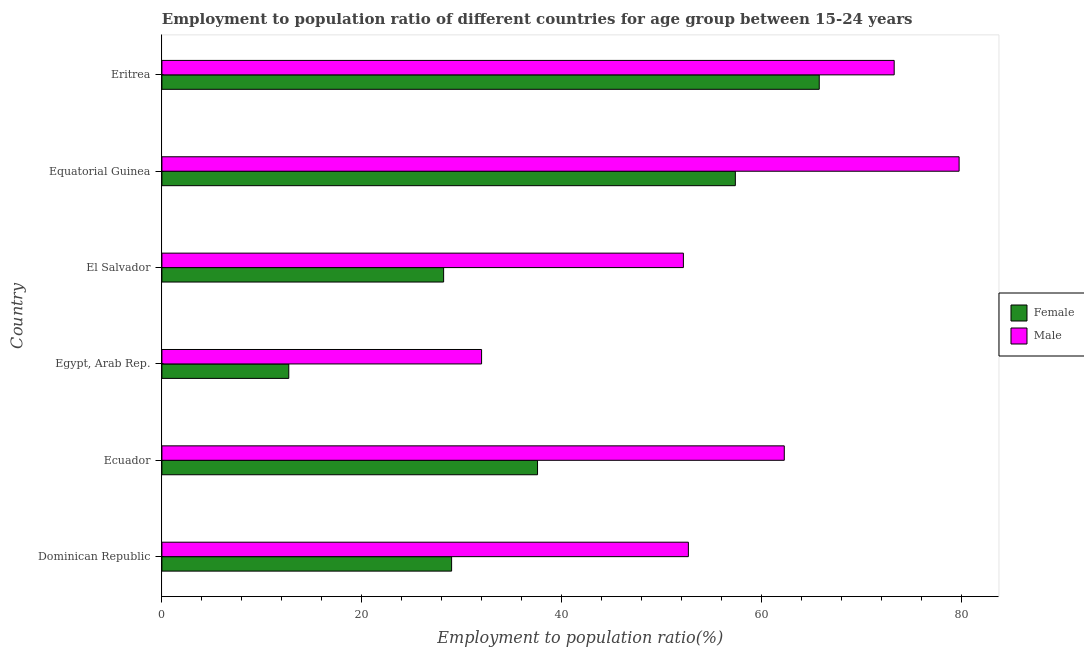How many groups of bars are there?
Provide a succinct answer. 6. Are the number of bars per tick equal to the number of legend labels?
Keep it short and to the point. Yes. Are the number of bars on each tick of the Y-axis equal?
Provide a succinct answer. Yes. What is the label of the 1st group of bars from the top?
Your answer should be very brief. Eritrea. In how many cases, is the number of bars for a given country not equal to the number of legend labels?
Give a very brief answer. 0. What is the employment to population ratio(male) in Equatorial Guinea?
Your response must be concise. 79.8. Across all countries, what is the maximum employment to population ratio(female)?
Keep it short and to the point. 65.8. Across all countries, what is the minimum employment to population ratio(female)?
Offer a terse response. 12.7. In which country was the employment to population ratio(male) maximum?
Offer a very short reply. Equatorial Guinea. In which country was the employment to population ratio(female) minimum?
Your answer should be very brief. Egypt, Arab Rep. What is the total employment to population ratio(male) in the graph?
Provide a short and direct response. 352.3. What is the difference between the employment to population ratio(male) in Ecuador and that in Eritrea?
Provide a succinct answer. -11. What is the difference between the employment to population ratio(female) in Equatorial Guinea and the employment to population ratio(male) in Egypt, Arab Rep.?
Your answer should be very brief. 25.4. What is the average employment to population ratio(male) per country?
Your answer should be very brief. 58.72. What is the difference between the employment to population ratio(female) and employment to population ratio(male) in Dominican Republic?
Provide a succinct answer. -23.7. In how many countries, is the employment to population ratio(male) greater than 44 %?
Offer a very short reply. 5. What is the ratio of the employment to population ratio(male) in Dominican Republic to that in Ecuador?
Provide a short and direct response. 0.85. What is the difference between the highest and the lowest employment to population ratio(male)?
Offer a very short reply. 47.8. In how many countries, is the employment to population ratio(male) greater than the average employment to population ratio(male) taken over all countries?
Ensure brevity in your answer.  3. Is the sum of the employment to population ratio(female) in Egypt, Arab Rep. and El Salvador greater than the maximum employment to population ratio(male) across all countries?
Offer a very short reply. No. Are all the bars in the graph horizontal?
Your answer should be compact. Yes. How many countries are there in the graph?
Ensure brevity in your answer.  6. What is the difference between two consecutive major ticks on the X-axis?
Ensure brevity in your answer.  20. Are the values on the major ticks of X-axis written in scientific E-notation?
Offer a very short reply. No. Does the graph contain any zero values?
Make the answer very short. No. Does the graph contain grids?
Offer a terse response. No. What is the title of the graph?
Offer a very short reply. Employment to population ratio of different countries for age group between 15-24 years. What is the label or title of the Y-axis?
Offer a terse response. Country. What is the Employment to population ratio(%) of Female in Dominican Republic?
Provide a short and direct response. 29. What is the Employment to population ratio(%) of Male in Dominican Republic?
Offer a very short reply. 52.7. What is the Employment to population ratio(%) in Female in Ecuador?
Make the answer very short. 37.6. What is the Employment to population ratio(%) of Male in Ecuador?
Ensure brevity in your answer.  62.3. What is the Employment to population ratio(%) in Female in Egypt, Arab Rep.?
Provide a succinct answer. 12.7. What is the Employment to population ratio(%) in Male in Egypt, Arab Rep.?
Make the answer very short. 32. What is the Employment to population ratio(%) of Female in El Salvador?
Your answer should be compact. 28.2. What is the Employment to population ratio(%) in Male in El Salvador?
Offer a terse response. 52.2. What is the Employment to population ratio(%) in Female in Equatorial Guinea?
Your response must be concise. 57.4. What is the Employment to population ratio(%) in Male in Equatorial Guinea?
Provide a short and direct response. 79.8. What is the Employment to population ratio(%) of Female in Eritrea?
Offer a terse response. 65.8. What is the Employment to population ratio(%) in Male in Eritrea?
Provide a short and direct response. 73.3. Across all countries, what is the maximum Employment to population ratio(%) of Female?
Your response must be concise. 65.8. Across all countries, what is the maximum Employment to population ratio(%) of Male?
Offer a very short reply. 79.8. Across all countries, what is the minimum Employment to population ratio(%) in Female?
Make the answer very short. 12.7. Across all countries, what is the minimum Employment to population ratio(%) in Male?
Your response must be concise. 32. What is the total Employment to population ratio(%) in Female in the graph?
Your response must be concise. 230.7. What is the total Employment to population ratio(%) in Male in the graph?
Your answer should be very brief. 352.3. What is the difference between the Employment to population ratio(%) in Male in Dominican Republic and that in Ecuador?
Your answer should be compact. -9.6. What is the difference between the Employment to population ratio(%) of Female in Dominican Republic and that in Egypt, Arab Rep.?
Your answer should be very brief. 16.3. What is the difference between the Employment to population ratio(%) in Male in Dominican Republic and that in Egypt, Arab Rep.?
Offer a very short reply. 20.7. What is the difference between the Employment to population ratio(%) in Female in Dominican Republic and that in El Salvador?
Give a very brief answer. 0.8. What is the difference between the Employment to population ratio(%) in Male in Dominican Republic and that in El Salvador?
Your answer should be compact. 0.5. What is the difference between the Employment to population ratio(%) in Female in Dominican Republic and that in Equatorial Guinea?
Provide a succinct answer. -28.4. What is the difference between the Employment to population ratio(%) in Male in Dominican Republic and that in Equatorial Guinea?
Your answer should be very brief. -27.1. What is the difference between the Employment to population ratio(%) in Female in Dominican Republic and that in Eritrea?
Keep it short and to the point. -36.8. What is the difference between the Employment to population ratio(%) in Male in Dominican Republic and that in Eritrea?
Your answer should be compact. -20.6. What is the difference between the Employment to population ratio(%) in Female in Ecuador and that in Egypt, Arab Rep.?
Your answer should be very brief. 24.9. What is the difference between the Employment to population ratio(%) in Male in Ecuador and that in Egypt, Arab Rep.?
Provide a short and direct response. 30.3. What is the difference between the Employment to population ratio(%) in Female in Ecuador and that in Equatorial Guinea?
Offer a very short reply. -19.8. What is the difference between the Employment to population ratio(%) in Male in Ecuador and that in Equatorial Guinea?
Keep it short and to the point. -17.5. What is the difference between the Employment to population ratio(%) in Female in Ecuador and that in Eritrea?
Offer a terse response. -28.2. What is the difference between the Employment to population ratio(%) in Male in Ecuador and that in Eritrea?
Provide a succinct answer. -11. What is the difference between the Employment to population ratio(%) of Female in Egypt, Arab Rep. and that in El Salvador?
Provide a short and direct response. -15.5. What is the difference between the Employment to population ratio(%) in Male in Egypt, Arab Rep. and that in El Salvador?
Keep it short and to the point. -20.2. What is the difference between the Employment to population ratio(%) in Female in Egypt, Arab Rep. and that in Equatorial Guinea?
Keep it short and to the point. -44.7. What is the difference between the Employment to population ratio(%) in Male in Egypt, Arab Rep. and that in Equatorial Guinea?
Your answer should be compact. -47.8. What is the difference between the Employment to population ratio(%) in Female in Egypt, Arab Rep. and that in Eritrea?
Keep it short and to the point. -53.1. What is the difference between the Employment to population ratio(%) in Male in Egypt, Arab Rep. and that in Eritrea?
Ensure brevity in your answer.  -41.3. What is the difference between the Employment to population ratio(%) of Female in El Salvador and that in Equatorial Guinea?
Your answer should be compact. -29.2. What is the difference between the Employment to population ratio(%) in Male in El Salvador and that in Equatorial Guinea?
Your answer should be very brief. -27.6. What is the difference between the Employment to population ratio(%) of Female in El Salvador and that in Eritrea?
Keep it short and to the point. -37.6. What is the difference between the Employment to population ratio(%) in Male in El Salvador and that in Eritrea?
Give a very brief answer. -21.1. What is the difference between the Employment to population ratio(%) of Female in Equatorial Guinea and that in Eritrea?
Keep it short and to the point. -8.4. What is the difference between the Employment to population ratio(%) in Male in Equatorial Guinea and that in Eritrea?
Offer a very short reply. 6.5. What is the difference between the Employment to population ratio(%) of Female in Dominican Republic and the Employment to population ratio(%) of Male in Ecuador?
Ensure brevity in your answer.  -33.3. What is the difference between the Employment to population ratio(%) in Female in Dominican Republic and the Employment to population ratio(%) in Male in El Salvador?
Your response must be concise. -23.2. What is the difference between the Employment to population ratio(%) in Female in Dominican Republic and the Employment to population ratio(%) in Male in Equatorial Guinea?
Provide a short and direct response. -50.8. What is the difference between the Employment to population ratio(%) of Female in Dominican Republic and the Employment to population ratio(%) of Male in Eritrea?
Your answer should be very brief. -44.3. What is the difference between the Employment to population ratio(%) of Female in Ecuador and the Employment to population ratio(%) of Male in Egypt, Arab Rep.?
Offer a very short reply. 5.6. What is the difference between the Employment to population ratio(%) in Female in Ecuador and the Employment to population ratio(%) in Male in El Salvador?
Offer a terse response. -14.6. What is the difference between the Employment to population ratio(%) in Female in Ecuador and the Employment to population ratio(%) in Male in Equatorial Guinea?
Offer a terse response. -42.2. What is the difference between the Employment to population ratio(%) in Female in Ecuador and the Employment to population ratio(%) in Male in Eritrea?
Your answer should be compact. -35.7. What is the difference between the Employment to population ratio(%) of Female in Egypt, Arab Rep. and the Employment to population ratio(%) of Male in El Salvador?
Your answer should be compact. -39.5. What is the difference between the Employment to population ratio(%) in Female in Egypt, Arab Rep. and the Employment to population ratio(%) in Male in Equatorial Guinea?
Provide a succinct answer. -67.1. What is the difference between the Employment to population ratio(%) in Female in Egypt, Arab Rep. and the Employment to population ratio(%) in Male in Eritrea?
Your answer should be compact. -60.6. What is the difference between the Employment to population ratio(%) in Female in El Salvador and the Employment to population ratio(%) in Male in Equatorial Guinea?
Your response must be concise. -51.6. What is the difference between the Employment to population ratio(%) in Female in El Salvador and the Employment to population ratio(%) in Male in Eritrea?
Your answer should be compact. -45.1. What is the difference between the Employment to population ratio(%) in Female in Equatorial Guinea and the Employment to population ratio(%) in Male in Eritrea?
Offer a very short reply. -15.9. What is the average Employment to population ratio(%) of Female per country?
Provide a succinct answer. 38.45. What is the average Employment to population ratio(%) in Male per country?
Provide a short and direct response. 58.72. What is the difference between the Employment to population ratio(%) of Female and Employment to population ratio(%) of Male in Dominican Republic?
Make the answer very short. -23.7. What is the difference between the Employment to population ratio(%) of Female and Employment to population ratio(%) of Male in Ecuador?
Your answer should be very brief. -24.7. What is the difference between the Employment to population ratio(%) of Female and Employment to population ratio(%) of Male in Egypt, Arab Rep.?
Keep it short and to the point. -19.3. What is the difference between the Employment to population ratio(%) of Female and Employment to population ratio(%) of Male in Equatorial Guinea?
Provide a succinct answer. -22.4. What is the ratio of the Employment to population ratio(%) in Female in Dominican Republic to that in Ecuador?
Offer a terse response. 0.77. What is the ratio of the Employment to population ratio(%) of Male in Dominican Republic to that in Ecuador?
Make the answer very short. 0.85. What is the ratio of the Employment to population ratio(%) of Female in Dominican Republic to that in Egypt, Arab Rep.?
Offer a terse response. 2.28. What is the ratio of the Employment to population ratio(%) in Male in Dominican Republic to that in Egypt, Arab Rep.?
Make the answer very short. 1.65. What is the ratio of the Employment to population ratio(%) of Female in Dominican Republic to that in El Salvador?
Provide a succinct answer. 1.03. What is the ratio of the Employment to population ratio(%) of Male in Dominican Republic to that in El Salvador?
Keep it short and to the point. 1.01. What is the ratio of the Employment to population ratio(%) in Female in Dominican Republic to that in Equatorial Guinea?
Provide a short and direct response. 0.51. What is the ratio of the Employment to population ratio(%) of Male in Dominican Republic to that in Equatorial Guinea?
Ensure brevity in your answer.  0.66. What is the ratio of the Employment to population ratio(%) in Female in Dominican Republic to that in Eritrea?
Offer a very short reply. 0.44. What is the ratio of the Employment to population ratio(%) in Male in Dominican Republic to that in Eritrea?
Provide a succinct answer. 0.72. What is the ratio of the Employment to population ratio(%) in Female in Ecuador to that in Egypt, Arab Rep.?
Offer a terse response. 2.96. What is the ratio of the Employment to population ratio(%) of Male in Ecuador to that in Egypt, Arab Rep.?
Your response must be concise. 1.95. What is the ratio of the Employment to population ratio(%) in Female in Ecuador to that in El Salvador?
Your response must be concise. 1.33. What is the ratio of the Employment to population ratio(%) of Male in Ecuador to that in El Salvador?
Offer a very short reply. 1.19. What is the ratio of the Employment to population ratio(%) of Female in Ecuador to that in Equatorial Guinea?
Ensure brevity in your answer.  0.66. What is the ratio of the Employment to population ratio(%) of Male in Ecuador to that in Equatorial Guinea?
Provide a short and direct response. 0.78. What is the ratio of the Employment to population ratio(%) in Male in Ecuador to that in Eritrea?
Provide a succinct answer. 0.85. What is the ratio of the Employment to population ratio(%) of Female in Egypt, Arab Rep. to that in El Salvador?
Your response must be concise. 0.45. What is the ratio of the Employment to population ratio(%) in Male in Egypt, Arab Rep. to that in El Salvador?
Offer a very short reply. 0.61. What is the ratio of the Employment to population ratio(%) in Female in Egypt, Arab Rep. to that in Equatorial Guinea?
Provide a short and direct response. 0.22. What is the ratio of the Employment to population ratio(%) of Male in Egypt, Arab Rep. to that in Equatorial Guinea?
Give a very brief answer. 0.4. What is the ratio of the Employment to population ratio(%) of Female in Egypt, Arab Rep. to that in Eritrea?
Make the answer very short. 0.19. What is the ratio of the Employment to population ratio(%) of Male in Egypt, Arab Rep. to that in Eritrea?
Your answer should be compact. 0.44. What is the ratio of the Employment to population ratio(%) of Female in El Salvador to that in Equatorial Guinea?
Keep it short and to the point. 0.49. What is the ratio of the Employment to population ratio(%) of Male in El Salvador to that in Equatorial Guinea?
Your response must be concise. 0.65. What is the ratio of the Employment to population ratio(%) of Female in El Salvador to that in Eritrea?
Your answer should be very brief. 0.43. What is the ratio of the Employment to population ratio(%) in Male in El Salvador to that in Eritrea?
Offer a very short reply. 0.71. What is the ratio of the Employment to population ratio(%) of Female in Equatorial Guinea to that in Eritrea?
Provide a short and direct response. 0.87. What is the ratio of the Employment to population ratio(%) in Male in Equatorial Guinea to that in Eritrea?
Offer a terse response. 1.09. What is the difference between the highest and the second highest Employment to population ratio(%) of Female?
Provide a short and direct response. 8.4. What is the difference between the highest and the lowest Employment to population ratio(%) in Female?
Make the answer very short. 53.1. What is the difference between the highest and the lowest Employment to population ratio(%) in Male?
Your response must be concise. 47.8. 